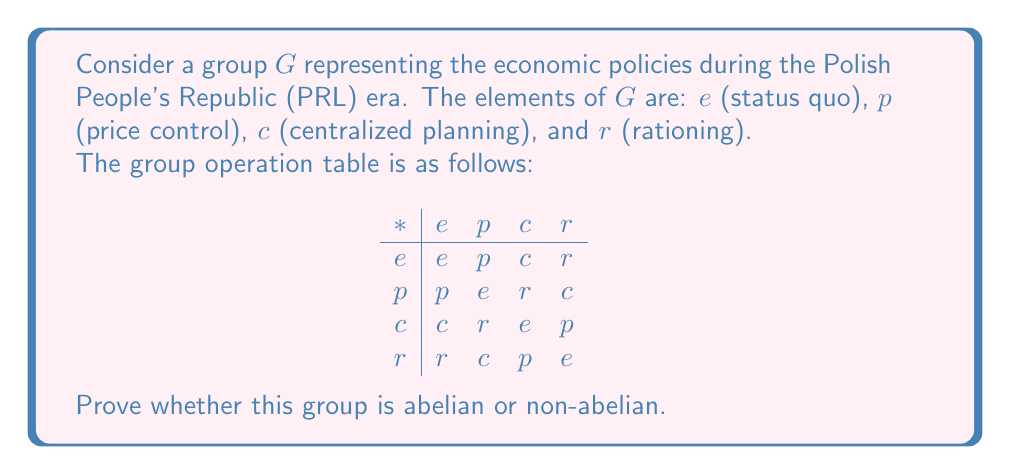Help me with this question. To determine whether the group $G$ is abelian or non-abelian, we need to check if the group operation is commutative for all pairs of elements. A group is abelian if and only if $a * b = b * a$ for all $a, b \in G$.

Let's examine the commutativity of each pair of distinct elements:

1. $e * a = a * e$ for all $a \in G$ (this is always true for the identity element)

2. $p * c = r$ and $c * p = r$
   $p * r = c$ and $r * p = c$

3. $c * r = p$ and $r * c = p$

We can see that for all pairs of elements $a, b \in G$, $a * b = b * a$. This means that the operation is commutative for all elements in the group.

Therefore, we can conclude that the group $G$ representing economic policies during the PRL era is abelian.

This result could be interpreted in the context of the PRL's economic system as follows: the interplay between different economic policies (price control, centralized planning, and rationing) was symmetric, meaning the order of application of these policies did not affect the overall economic outcome in this simplified model.
Answer: The group $G$ representing economic policies during the PRL era is abelian. 